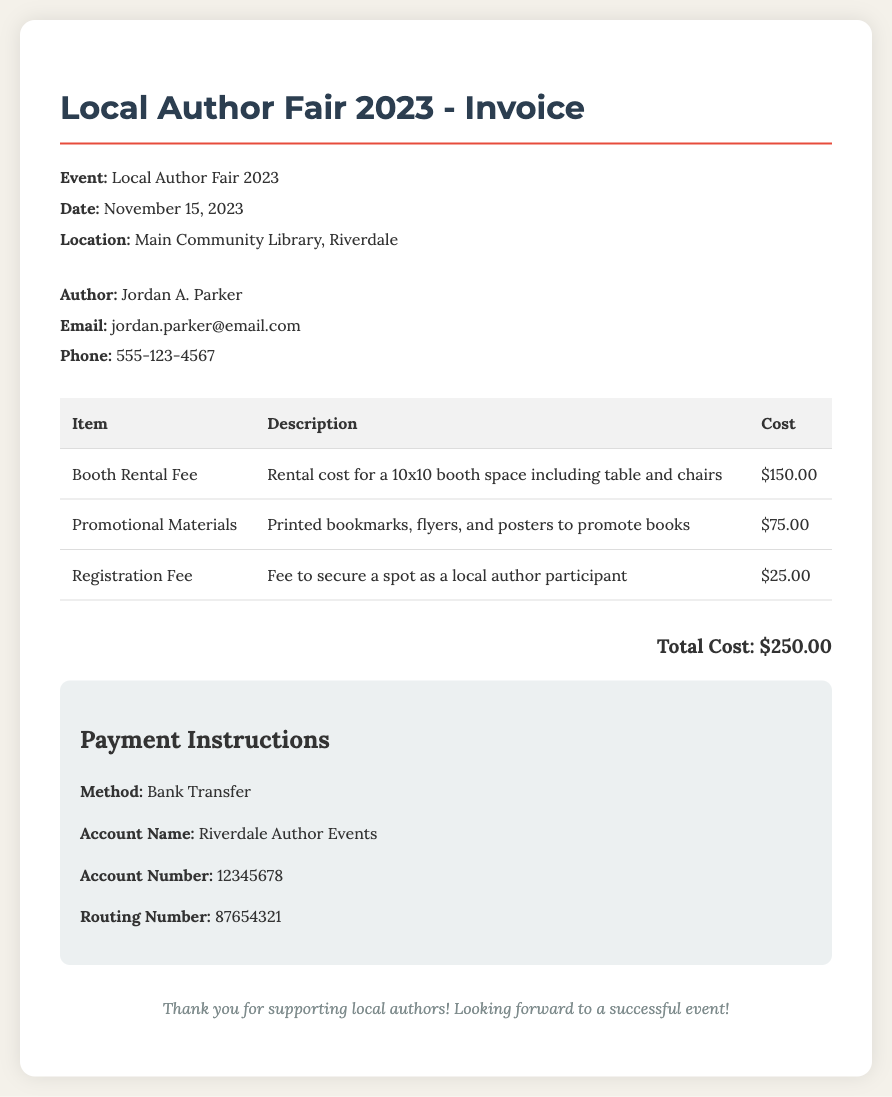What is the author's name? The author's name is listed in the document under "Author" information.
Answer: Jordan A. Parker What is the total cost? The total cost is prominently displayed at the bottom of the invoice.
Answer: $250.00 What is the date of the event? The date of the event is specified in the "Event" details section.
Answer: November 15, 2023 What type of payment method is accepted? The payment instructions section indicates the accepted payment method.
Answer: Bank Transfer What is included in the booth rental fee? The description for the booth rental fee provides details about inclusions.
Answer: 10x10 booth space including table and chairs How much is the booth rental fee? The cost for the booth rental fee can be found in the corresponding row of the itemized list.
Answer: $150.00 Where is the event located? The location of the event is clearly stated in the event details.
Answer: Main Community Library, Riverdale What is the purpose of the registration fee? The description for the registration fee explains its purpose.
Answer: To secure a spot as a local author participant What does the promotional materials cost cover? The description for promotional materials gives insights into what it includes.
Answer: Printed bookmarks, flyers, and posters to promote books 